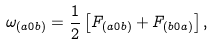<formula> <loc_0><loc_0><loc_500><loc_500>\omega _ { ( a 0 b ) } = \frac { 1 } { 2 } \left [ F _ { ( a 0 b ) } + F _ { ( b 0 a ) } \right ] ,</formula> 